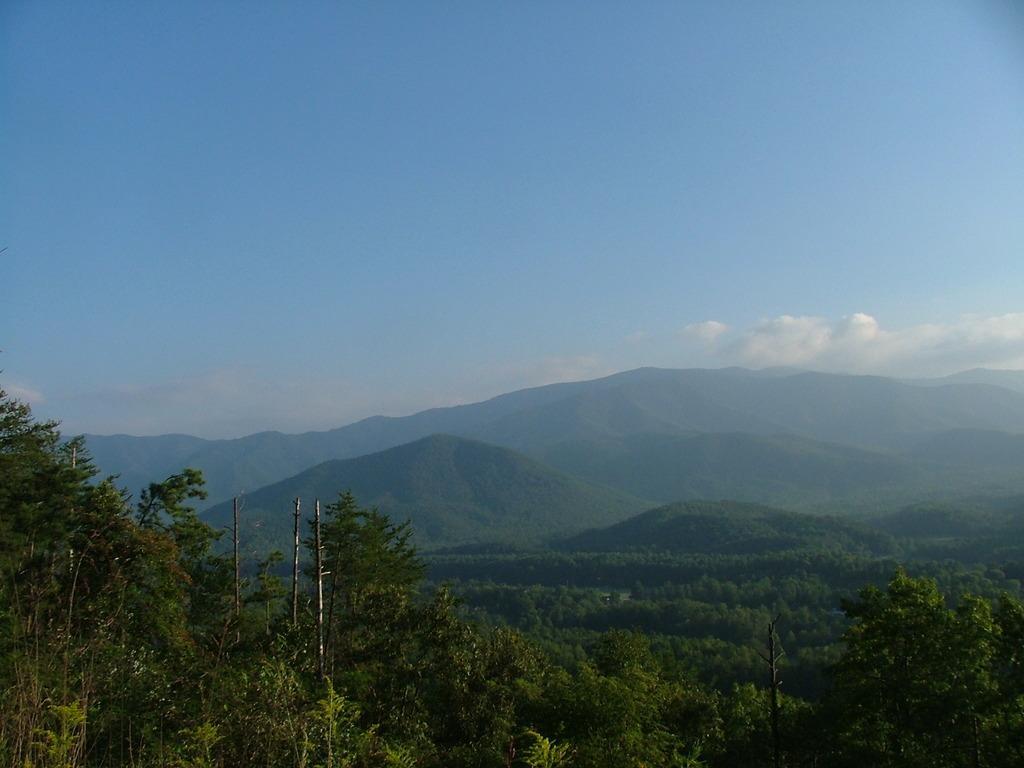Please provide a concise description of this image. In this image I can see there are trees at the bottom. At the top it is the sky. 